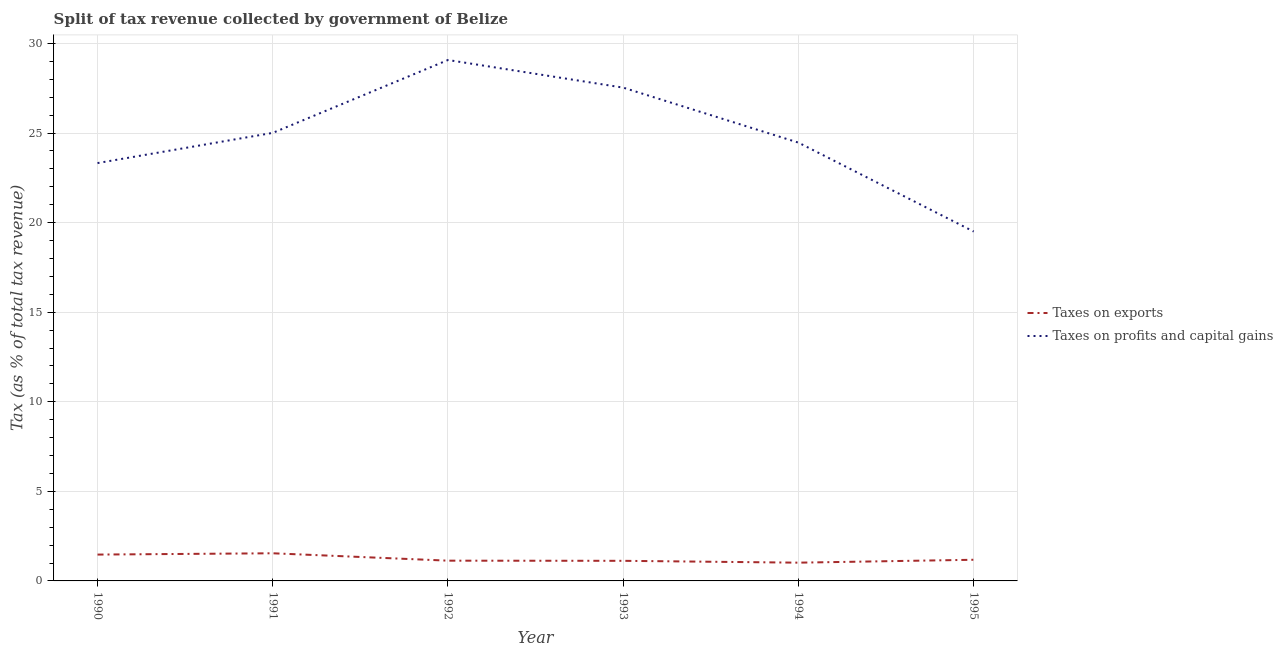How many different coloured lines are there?
Your answer should be very brief. 2. What is the percentage of revenue obtained from taxes on exports in 1994?
Offer a very short reply. 1.02. Across all years, what is the maximum percentage of revenue obtained from taxes on profits and capital gains?
Provide a short and direct response. 29.08. Across all years, what is the minimum percentage of revenue obtained from taxes on profits and capital gains?
Your answer should be compact. 19.5. In which year was the percentage of revenue obtained from taxes on profits and capital gains maximum?
Keep it short and to the point. 1992. What is the total percentage of revenue obtained from taxes on exports in the graph?
Offer a terse response. 7.47. What is the difference between the percentage of revenue obtained from taxes on exports in 1990 and that in 1992?
Make the answer very short. 0.34. What is the difference between the percentage of revenue obtained from taxes on exports in 1992 and the percentage of revenue obtained from taxes on profits and capital gains in 1991?
Your answer should be very brief. -23.88. What is the average percentage of revenue obtained from taxes on exports per year?
Make the answer very short. 1.24. In the year 1992, what is the difference between the percentage of revenue obtained from taxes on exports and percentage of revenue obtained from taxes on profits and capital gains?
Your response must be concise. -27.95. What is the ratio of the percentage of revenue obtained from taxes on profits and capital gains in 1991 to that in 1994?
Keep it short and to the point. 1.02. What is the difference between the highest and the second highest percentage of revenue obtained from taxes on profits and capital gains?
Ensure brevity in your answer.  1.54. What is the difference between the highest and the lowest percentage of revenue obtained from taxes on exports?
Your response must be concise. 0.52. Is the percentage of revenue obtained from taxes on profits and capital gains strictly greater than the percentage of revenue obtained from taxes on exports over the years?
Make the answer very short. Yes. Is the percentage of revenue obtained from taxes on exports strictly less than the percentage of revenue obtained from taxes on profits and capital gains over the years?
Ensure brevity in your answer.  Yes. How many years are there in the graph?
Provide a succinct answer. 6. Are the values on the major ticks of Y-axis written in scientific E-notation?
Ensure brevity in your answer.  No. Does the graph contain grids?
Give a very brief answer. Yes. Where does the legend appear in the graph?
Your response must be concise. Center right. How many legend labels are there?
Give a very brief answer. 2. How are the legend labels stacked?
Give a very brief answer. Vertical. What is the title of the graph?
Keep it short and to the point. Split of tax revenue collected by government of Belize. Does "Food and tobacco" appear as one of the legend labels in the graph?
Keep it short and to the point. No. What is the label or title of the Y-axis?
Your answer should be compact. Tax (as % of total tax revenue). What is the Tax (as % of total tax revenue) of Taxes on exports in 1990?
Your response must be concise. 1.47. What is the Tax (as % of total tax revenue) of Taxes on profits and capital gains in 1990?
Offer a very short reply. 23.33. What is the Tax (as % of total tax revenue) in Taxes on exports in 1991?
Provide a short and direct response. 1.54. What is the Tax (as % of total tax revenue) of Taxes on profits and capital gains in 1991?
Your answer should be very brief. 25.01. What is the Tax (as % of total tax revenue) of Taxes on exports in 1992?
Ensure brevity in your answer.  1.13. What is the Tax (as % of total tax revenue) of Taxes on profits and capital gains in 1992?
Provide a short and direct response. 29.08. What is the Tax (as % of total tax revenue) of Taxes on exports in 1993?
Provide a succinct answer. 1.12. What is the Tax (as % of total tax revenue) in Taxes on profits and capital gains in 1993?
Your answer should be compact. 27.54. What is the Tax (as % of total tax revenue) in Taxes on exports in 1994?
Your response must be concise. 1.02. What is the Tax (as % of total tax revenue) of Taxes on profits and capital gains in 1994?
Your answer should be very brief. 24.47. What is the Tax (as % of total tax revenue) of Taxes on exports in 1995?
Your response must be concise. 1.18. What is the Tax (as % of total tax revenue) in Taxes on profits and capital gains in 1995?
Offer a terse response. 19.5. Across all years, what is the maximum Tax (as % of total tax revenue) in Taxes on exports?
Offer a very short reply. 1.54. Across all years, what is the maximum Tax (as % of total tax revenue) of Taxes on profits and capital gains?
Offer a very short reply. 29.08. Across all years, what is the minimum Tax (as % of total tax revenue) of Taxes on exports?
Provide a succinct answer. 1.02. Across all years, what is the minimum Tax (as % of total tax revenue) of Taxes on profits and capital gains?
Provide a succinct answer. 19.5. What is the total Tax (as % of total tax revenue) of Taxes on exports in the graph?
Your response must be concise. 7.47. What is the total Tax (as % of total tax revenue) of Taxes on profits and capital gains in the graph?
Provide a succinct answer. 148.92. What is the difference between the Tax (as % of total tax revenue) of Taxes on exports in 1990 and that in 1991?
Keep it short and to the point. -0.07. What is the difference between the Tax (as % of total tax revenue) of Taxes on profits and capital gains in 1990 and that in 1991?
Make the answer very short. -1.69. What is the difference between the Tax (as % of total tax revenue) in Taxes on exports in 1990 and that in 1992?
Make the answer very short. 0.34. What is the difference between the Tax (as % of total tax revenue) of Taxes on profits and capital gains in 1990 and that in 1992?
Your answer should be compact. -5.75. What is the difference between the Tax (as % of total tax revenue) in Taxes on exports in 1990 and that in 1993?
Make the answer very short. 0.35. What is the difference between the Tax (as % of total tax revenue) of Taxes on profits and capital gains in 1990 and that in 1993?
Your response must be concise. -4.21. What is the difference between the Tax (as % of total tax revenue) of Taxes on exports in 1990 and that in 1994?
Make the answer very short. 0.45. What is the difference between the Tax (as % of total tax revenue) of Taxes on profits and capital gains in 1990 and that in 1994?
Give a very brief answer. -1.14. What is the difference between the Tax (as % of total tax revenue) of Taxes on exports in 1990 and that in 1995?
Keep it short and to the point. 0.29. What is the difference between the Tax (as % of total tax revenue) in Taxes on profits and capital gains in 1990 and that in 1995?
Ensure brevity in your answer.  3.82. What is the difference between the Tax (as % of total tax revenue) of Taxes on exports in 1991 and that in 1992?
Provide a short and direct response. 0.41. What is the difference between the Tax (as % of total tax revenue) of Taxes on profits and capital gains in 1991 and that in 1992?
Provide a short and direct response. -4.07. What is the difference between the Tax (as % of total tax revenue) of Taxes on exports in 1991 and that in 1993?
Offer a terse response. 0.42. What is the difference between the Tax (as % of total tax revenue) in Taxes on profits and capital gains in 1991 and that in 1993?
Make the answer very short. -2.52. What is the difference between the Tax (as % of total tax revenue) of Taxes on exports in 1991 and that in 1994?
Offer a very short reply. 0.52. What is the difference between the Tax (as % of total tax revenue) of Taxes on profits and capital gains in 1991 and that in 1994?
Offer a very short reply. 0.55. What is the difference between the Tax (as % of total tax revenue) in Taxes on exports in 1991 and that in 1995?
Offer a terse response. 0.36. What is the difference between the Tax (as % of total tax revenue) of Taxes on profits and capital gains in 1991 and that in 1995?
Your answer should be compact. 5.51. What is the difference between the Tax (as % of total tax revenue) of Taxes on exports in 1992 and that in 1993?
Your response must be concise. 0.01. What is the difference between the Tax (as % of total tax revenue) in Taxes on profits and capital gains in 1992 and that in 1993?
Provide a succinct answer. 1.54. What is the difference between the Tax (as % of total tax revenue) of Taxes on exports in 1992 and that in 1994?
Your answer should be compact. 0.11. What is the difference between the Tax (as % of total tax revenue) in Taxes on profits and capital gains in 1992 and that in 1994?
Ensure brevity in your answer.  4.61. What is the difference between the Tax (as % of total tax revenue) of Taxes on exports in 1992 and that in 1995?
Ensure brevity in your answer.  -0.05. What is the difference between the Tax (as % of total tax revenue) of Taxes on profits and capital gains in 1992 and that in 1995?
Provide a succinct answer. 9.58. What is the difference between the Tax (as % of total tax revenue) of Taxes on exports in 1993 and that in 1994?
Your answer should be compact. 0.1. What is the difference between the Tax (as % of total tax revenue) in Taxes on profits and capital gains in 1993 and that in 1994?
Give a very brief answer. 3.07. What is the difference between the Tax (as % of total tax revenue) of Taxes on exports in 1993 and that in 1995?
Offer a very short reply. -0.06. What is the difference between the Tax (as % of total tax revenue) in Taxes on profits and capital gains in 1993 and that in 1995?
Ensure brevity in your answer.  8.03. What is the difference between the Tax (as % of total tax revenue) of Taxes on exports in 1994 and that in 1995?
Offer a very short reply. -0.16. What is the difference between the Tax (as % of total tax revenue) in Taxes on profits and capital gains in 1994 and that in 1995?
Give a very brief answer. 4.96. What is the difference between the Tax (as % of total tax revenue) in Taxes on exports in 1990 and the Tax (as % of total tax revenue) in Taxes on profits and capital gains in 1991?
Provide a succinct answer. -23.54. What is the difference between the Tax (as % of total tax revenue) of Taxes on exports in 1990 and the Tax (as % of total tax revenue) of Taxes on profits and capital gains in 1992?
Offer a very short reply. -27.61. What is the difference between the Tax (as % of total tax revenue) of Taxes on exports in 1990 and the Tax (as % of total tax revenue) of Taxes on profits and capital gains in 1993?
Give a very brief answer. -26.07. What is the difference between the Tax (as % of total tax revenue) in Taxes on exports in 1990 and the Tax (as % of total tax revenue) in Taxes on profits and capital gains in 1994?
Ensure brevity in your answer.  -23. What is the difference between the Tax (as % of total tax revenue) in Taxes on exports in 1990 and the Tax (as % of total tax revenue) in Taxes on profits and capital gains in 1995?
Provide a succinct answer. -18.03. What is the difference between the Tax (as % of total tax revenue) in Taxes on exports in 1991 and the Tax (as % of total tax revenue) in Taxes on profits and capital gains in 1992?
Keep it short and to the point. -27.54. What is the difference between the Tax (as % of total tax revenue) of Taxes on exports in 1991 and the Tax (as % of total tax revenue) of Taxes on profits and capital gains in 1993?
Keep it short and to the point. -25.99. What is the difference between the Tax (as % of total tax revenue) of Taxes on exports in 1991 and the Tax (as % of total tax revenue) of Taxes on profits and capital gains in 1994?
Offer a very short reply. -22.92. What is the difference between the Tax (as % of total tax revenue) in Taxes on exports in 1991 and the Tax (as % of total tax revenue) in Taxes on profits and capital gains in 1995?
Provide a succinct answer. -17.96. What is the difference between the Tax (as % of total tax revenue) in Taxes on exports in 1992 and the Tax (as % of total tax revenue) in Taxes on profits and capital gains in 1993?
Offer a terse response. -26.41. What is the difference between the Tax (as % of total tax revenue) in Taxes on exports in 1992 and the Tax (as % of total tax revenue) in Taxes on profits and capital gains in 1994?
Your answer should be very brief. -23.34. What is the difference between the Tax (as % of total tax revenue) of Taxes on exports in 1992 and the Tax (as % of total tax revenue) of Taxes on profits and capital gains in 1995?
Your answer should be very brief. -18.37. What is the difference between the Tax (as % of total tax revenue) of Taxes on exports in 1993 and the Tax (as % of total tax revenue) of Taxes on profits and capital gains in 1994?
Your response must be concise. -23.34. What is the difference between the Tax (as % of total tax revenue) in Taxes on exports in 1993 and the Tax (as % of total tax revenue) in Taxes on profits and capital gains in 1995?
Provide a short and direct response. -18.38. What is the difference between the Tax (as % of total tax revenue) in Taxes on exports in 1994 and the Tax (as % of total tax revenue) in Taxes on profits and capital gains in 1995?
Offer a very short reply. -18.48. What is the average Tax (as % of total tax revenue) of Taxes on exports per year?
Give a very brief answer. 1.24. What is the average Tax (as % of total tax revenue) of Taxes on profits and capital gains per year?
Provide a short and direct response. 24.82. In the year 1990, what is the difference between the Tax (as % of total tax revenue) of Taxes on exports and Tax (as % of total tax revenue) of Taxes on profits and capital gains?
Your response must be concise. -21.85. In the year 1991, what is the difference between the Tax (as % of total tax revenue) in Taxes on exports and Tax (as % of total tax revenue) in Taxes on profits and capital gains?
Ensure brevity in your answer.  -23.47. In the year 1992, what is the difference between the Tax (as % of total tax revenue) in Taxes on exports and Tax (as % of total tax revenue) in Taxes on profits and capital gains?
Offer a very short reply. -27.95. In the year 1993, what is the difference between the Tax (as % of total tax revenue) in Taxes on exports and Tax (as % of total tax revenue) in Taxes on profits and capital gains?
Provide a short and direct response. -26.41. In the year 1994, what is the difference between the Tax (as % of total tax revenue) of Taxes on exports and Tax (as % of total tax revenue) of Taxes on profits and capital gains?
Give a very brief answer. -23.45. In the year 1995, what is the difference between the Tax (as % of total tax revenue) of Taxes on exports and Tax (as % of total tax revenue) of Taxes on profits and capital gains?
Make the answer very short. -18.32. What is the ratio of the Tax (as % of total tax revenue) in Taxes on exports in 1990 to that in 1991?
Offer a terse response. 0.95. What is the ratio of the Tax (as % of total tax revenue) in Taxes on profits and capital gains in 1990 to that in 1991?
Offer a terse response. 0.93. What is the ratio of the Tax (as % of total tax revenue) of Taxes on exports in 1990 to that in 1992?
Offer a very short reply. 1.3. What is the ratio of the Tax (as % of total tax revenue) in Taxes on profits and capital gains in 1990 to that in 1992?
Your answer should be compact. 0.8. What is the ratio of the Tax (as % of total tax revenue) of Taxes on exports in 1990 to that in 1993?
Give a very brief answer. 1.31. What is the ratio of the Tax (as % of total tax revenue) in Taxes on profits and capital gains in 1990 to that in 1993?
Your response must be concise. 0.85. What is the ratio of the Tax (as % of total tax revenue) of Taxes on exports in 1990 to that in 1994?
Give a very brief answer. 1.44. What is the ratio of the Tax (as % of total tax revenue) in Taxes on profits and capital gains in 1990 to that in 1994?
Give a very brief answer. 0.95. What is the ratio of the Tax (as % of total tax revenue) in Taxes on exports in 1990 to that in 1995?
Offer a terse response. 1.25. What is the ratio of the Tax (as % of total tax revenue) of Taxes on profits and capital gains in 1990 to that in 1995?
Provide a short and direct response. 1.2. What is the ratio of the Tax (as % of total tax revenue) in Taxes on exports in 1991 to that in 1992?
Offer a very short reply. 1.37. What is the ratio of the Tax (as % of total tax revenue) of Taxes on profits and capital gains in 1991 to that in 1992?
Offer a very short reply. 0.86. What is the ratio of the Tax (as % of total tax revenue) in Taxes on exports in 1991 to that in 1993?
Ensure brevity in your answer.  1.38. What is the ratio of the Tax (as % of total tax revenue) in Taxes on profits and capital gains in 1991 to that in 1993?
Your answer should be compact. 0.91. What is the ratio of the Tax (as % of total tax revenue) in Taxes on exports in 1991 to that in 1994?
Offer a very short reply. 1.51. What is the ratio of the Tax (as % of total tax revenue) of Taxes on profits and capital gains in 1991 to that in 1994?
Offer a very short reply. 1.02. What is the ratio of the Tax (as % of total tax revenue) of Taxes on exports in 1991 to that in 1995?
Provide a short and direct response. 1.31. What is the ratio of the Tax (as % of total tax revenue) in Taxes on profits and capital gains in 1991 to that in 1995?
Your answer should be very brief. 1.28. What is the ratio of the Tax (as % of total tax revenue) of Taxes on exports in 1992 to that in 1993?
Keep it short and to the point. 1.01. What is the ratio of the Tax (as % of total tax revenue) in Taxes on profits and capital gains in 1992 to that in 1993?
Your answer should be very brief. 1.06. What is the ratio of the Tax (as % of total tax revenue) in Taxes on exports in 1992 to that in 1994?
Keep it short and to the point. 1.11. What is the ratio of the Tax (as % of total tax revenue) in Taxes on profits and capital gains in 1992 to that in 1994?
Your answer should be very brief. 1.19. What is the ratio of the Tax (as % of total tax revenue) in Taxes on exports in 1992 to that in 1995?
Provide a succinct answer. 0.96. What is the ratio of the Tax (as % of total tax revenue) in Taxes on profits and capital gains in 1992 to that in 1995?
Offer a terse response. 1.49. What is the ratio of the Tax (as % of total tax revenue) in Taxes on exports in 1993 to that in 1994?
Keep it short and to the point. 1.1. What is the ratio of the Tax (as % of total tax revenue) in Taxes on profits and capital gains in 1993 to that in 1994?
Provide a succinct answer. 1.13. What is the ratio of the Tax (as % of total tax revenue) of Taxes on exports in 1993 to that in 1995?
Give a very brief answer. 0.95. What is the ratio of the Tax (as % of total tax revenue) in Taxes on profits and capital gains in 1993 to that in 1995?
Provide a short and direct response. 1.41. What is the ratio of the Tax (as % of total tax revenue) in Taxes on exports in 1994 to that in 1995?
Offer a terse response. 0.86. What is the ratio of the Tax (as % of total tax revenue) of Taxes on profits and capital gains in 1994 to that in 1995?
Provide a succinct answer. 1.25. What is the difference between the highest and the second highest Tax (as % of total tax revenue) in Taxes on exports?
Ensure brevity in your answer.  0.07. What is the difference between the highest and the second highest Tax (as % of total tax revenue) in Taxes on profits and capital gains?
Ensure brevity in your answer.  1.54. What is the difference between the highest and the lowest Tax (as % of total tax revenue) in Taxes on exports?
Give a very brief answer. 0.52. What is the difference between the highest and the lowest Tax (as % of total tax revenue) of Taxes on profits and capital gains?
Your answer should be compact. 9.58. 